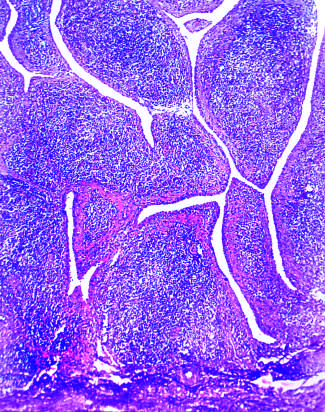does low magnification show marked synovial hypertrophy with formation of villi?
Answer the question using a single word or phrase. Yes 